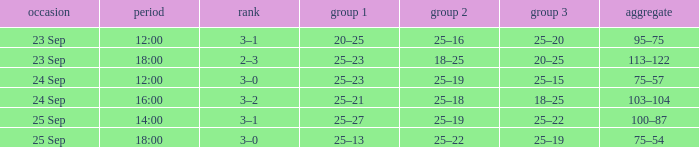What was the score when the time was 14:00? 3–1. 